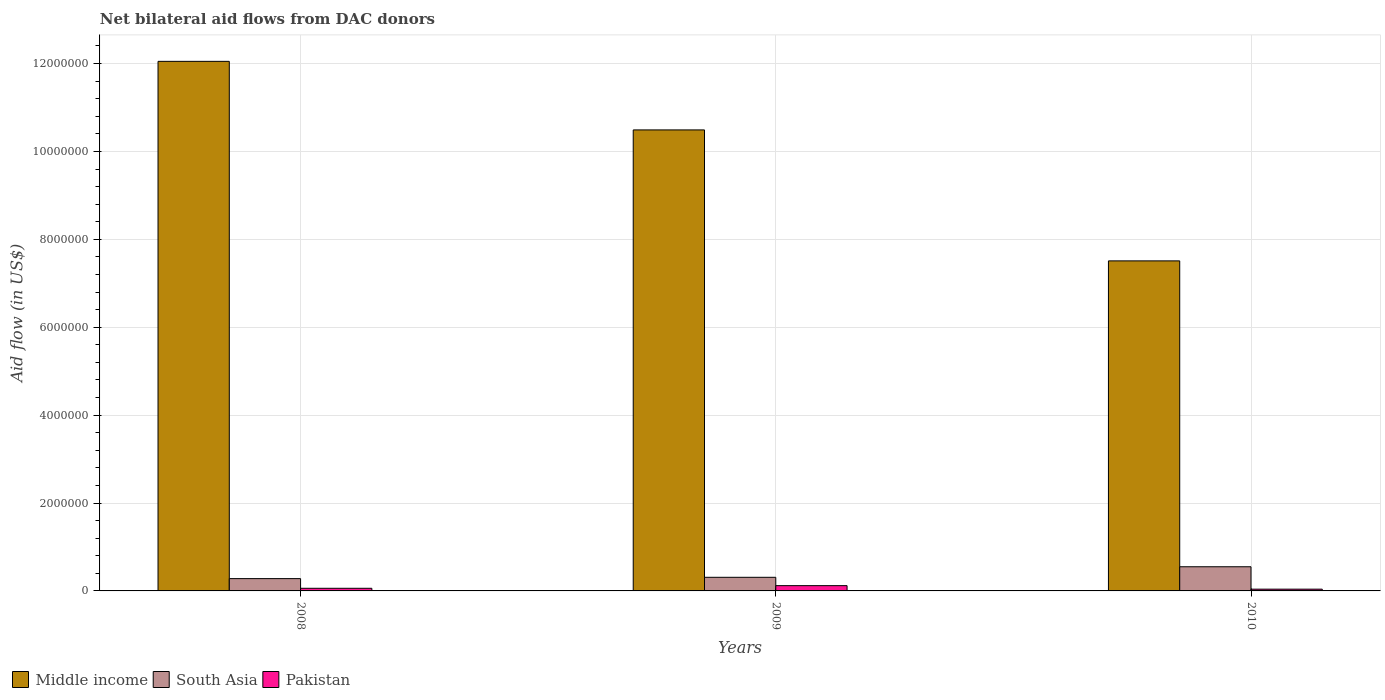How many different coloured bars are there?
Offer a terse response. 3. Are the number of bars on each tick of the X-axis equal?
Keep it short and to the point. Yes. How many bars are there on the 1st tick from the left?
Provide a short and direct response. 3. How many bars are there on the 1st tick from the right?
Offer a terse response. 3. In how many cases, is the number of bars for a given year not equal to the number of legend labels?
Your response must be concise. 0. What is the net bilateral aid flow in Pakistan in 2010?
Offer a very short reply. 4.00e+04. Across all years, what is the maximum net bilateral aid flow in South Asia?
Provide a short and direct response. 5.50e+05. In which year was the net bilateral aid flow in Pakistan minimum?
Your response must be concise. 2010. What is the total net bilateral aid flow in Middle income in the graph?
Give a very brief answer. 3.00e+07. What is the difference between the net bilateral aid flow in Middle income in 2009 and that in 2010?
Your answer should be very brief. 2.98e+06. What is the difference between the net bilateral aid flow in Pakistan in 2008 and the net bilateral aid flow in South Asia in 2010?
Give a very brief answer. -4.90e+05. What is the average net bilateral aid flow in Pakistan per year?
Your answer should be very brief. 7.33e+04. In the year 2008, what is the difference between the net bilateral aid flow in Pakistan and net bilateral aid flow in South Asia?
Ensure brevity in your answer.  -2.20e+05. In how many years, is the net bilateral aid flow in Pakistan greater than 5200000 US$?
Provide a succinct answer. 0. What is the ratio of the net bilateral aid flow in South Asia in 2008 to that in 2009?
Your answer should be very brief. 0.9. Is the difference between the net bilateral aid flow in Pakistan in 2008 and 2009 greater than the difference between the net bilateral aid flow in South Asia in 2008 and 2009?
Keep it short and to the point. No. What is the difference between the highest and the second highest net bilateral aid flow in Pakistan?
Offer a terse response. 6.00e+04. What does the 3rd bar from the left in 2010 represents?
Offer a very short reply. Pakistan. What does the 3rd bar from the right in 2008 represents?
Offer a terse response. Middle income. Is it the case that in every year, the sum of the net bilateral aid flow in Middle income and net bilateral aid flow in South Asia is greater than the net bilateral aid flow in Pakistan?
Your answer should be compact. Yes. How many bars are there?
Offer a terse response. 9. Are all the bars in the graph horizontal?
Your answer should be compact. No. Are the values on the major ticks of Y-axis written in scientific E-notation?
Keep it short and to the point. No. Where does the legend appear in the graph?
Offer a terse response. Bottom left. How are the legend labels stacked?
Ensure brevity in your answer.  Horizontal. What is the title of the graph?
Provide a succinct answer. Net bilateral aid flows from DAC donors. Does "Hungary" appear as one of the legend labels in the graph?
Offer a very short reply. No. What is the label or title of the Y-axis?
Provide a short and direct response. Aid flow (in US$). What is the Aid flow (in US$) of Middle income in 2008?
Provide a short and direct response. 1.20e+07. What is the Aid flow (in US$) in South Asia in 2008?
Provide a short and direct response. 2.80e+05. What is the Aid flow (in US$) of Middle income in 2009?
Keep it short and to the point. 1.05e+07. What is the Aid flow (in US$) in Pakistan in 2009?
Your answer should be compact. 1.20e+05. What is the Aid flow (in US$) in Middle income in 2010?
Give a very brief answer. 7.51e+06. What is the Aid flow (in US$) of South Asia in 2010?
Give a very brief answer. 5.50e+05. Across all years, what is the maximum Aid flow (in US$) in Middle income?
Your answer should be very brief. 1.20e+07. Across all years, what is the maximum Aid flow (in US$) in Pakistan?
Offer a very short reply. 1.20e+05. Across all years, what is the minimum Aid flow (in US$) in Middle income?
Your answer should be very brief. 7.51e+06. Across all years, what is the minimum Aid flow (in US$) of Pakistan?
Keep it short and to the point. 4.00e+04. What is the total Aid flow (in US$) of Middle income in the graph?
Your answer should be compact. 3.00e+07. What is the total Aid flow (in US$) in South Asia in the graph?
Offer a very short reply. 1.14e+06. What is the difference between the Aid flow (in US$) of Middle income in 2008 and that in 2009?
Offer a terse response. 1.56e+06. What is the difference between the Aid flow (in US$) in Middle income in 2008 and that in 2010?
Your response must be concise. 4.54e+06. What is the difference between the Aid flow (in US$) of South Asia in 2008 and that in 2010?
Offer a terse response. -2.70e+05. What is the difference between the Aid flow (in US$) in Pakistan in 2008 and that in 2010?
Offer a very short reply. 2.00e+04. What is the difference between the Aid flow (in US$) in Middle income in 2009 and that in 2010?
Your answer should be very brief. 2.98e+06. What is the difference between the Aid flow (in US$) in Pakistan in 2009 and that in 2010?
Give a very brief answer. 8.00e+04. What is the difference between the Aid flow (in US$) in Middle income in 2008 and the Aid flow (in US$) in South Asia in 2009?
Your answer should be compact. 1.17e+07. What is the difference between the Aid flow (in US$) in Middle income in 2008 and the Aid flow (in US$) in Pakistan in 2009?
Ensure brevity in your answer.  1.19e+07. What is the difference between the Aid flow (in US$) in South Asia in 2008 and the Aid flow (in US$) in Pakistan in 2009?
Give a very brief answer. 1.60e+05. What is the difference between the Aid flow (in US$) of Middle income in 2008 and the Aid flow (in US$) of South Asia in 2010?
Your answer should be compact. 1.15e+07. What is the difference between the Aid flow (in US$) of Middle income in 2008 and the Aid flow (in US$) of Pakistan in 2010?
Make the answer very short. 1.20e+07. What is the difference between the Aid flow (in US$) of South Asia in 2008 and the Aid flow (in US$) of Pakistan in 2010?
Ensure brevity in your answer.  2.40e+05. What is the difference between the Aid flow (in US$) of Middle income in 2009 and the Aid flow (in US$) of South Asia in 2010?
Give a very brief answer. 9.94e+06. What is the difference between the Aid flow (in US$) in Middle income in 2009 and the Aid flow (in US$) in Pakistan in 2010?
Ensure brevity in your answer.  1.04e+07. What is the difference between the Aid flow (in US$) of South Asia in 2009 and the Aid flow (in US$) of Pakistan in 2010?
Give a very brief answer. 2.70e+05. What is the average Aid flow (in US$) of Middle income per year?
Give a very brief answer. 1.00e+07. What is the average Aid flow (in US$) in Pakistan per year?
Ensure brevity in your answer.  7.33e+04. In the year 2008, what is the difference between the Aid flow (in US$) of Middle income and Aid flow (in US$) of South Asia?
Your response must be concise. 1.18e+07. In the year 2008, what is the difference between the Aid flow (in US$) in Middle income and Aid flow (in US$) in Pakistan?
Your response must be concise. 1.20e+07. In the year 2008, what is the difference between the Aid flow (in US$) of South Asia and Aid flow (in US$) of Pakistan?
Keep it short and to the point. 2.20e+05. In the year 2009, what is the difference between the Aid flow (in US$) of Middle income and Aid flow (in US$) of South Asia?
Your response must be concise. 1.02e+07. In the year 2009, what is the difference between the Aid flow (in US$) of Middle income and Aid flow (in US$) of Pakistan?
Ensure brevity in your answer.  1.04e+07. In the year 2009, what is the difference between the Aid flow (in US$) in South Asia and Aid flow (in US$) in Pakistan?
Your answer should be compact. 1.90e+05. In the year 2010, what is the difference between the Aid flow (in US$) of Middle income and Aid flow (in US$) of South Asia?
Provide a succinct answer. 6.96e+06. In the year 2010, what is the difference between the Aid flow (in US$) of Middle income and Aid flow (in US$) of Pakistan?
Keep it short and to the point. 7.47e+06. In the year 2010, what is the difference between the Aid flow (in US$) of South Asia and Aid flow (in US$) of Pakistan?
Offer a very short reply. 5.10e+05. What is the ratio of the Aid flow (in US$) in Middle income in 2008 to that in 2009?
Give a very brief answer. 1.15. What is the ratio of the Aid flow (in US$) of South Asia in 2008 to that in 2009?
Give a very brief answer. 0.9. What is the ratio of the Aid flow (in US$) in Middle income in 2008 to that in 2010?
Your answer should be compact. 1.6. What is the ratio of the Aid flow (in US$) in South Asia in 2008 to that in 2010?
Provide a short and direct response. 0.51. What is the ratio of the Aid flow (in US$) of Pakistan in 2008 to that in 2010?
Your response must be concise. 1.5. What is the ratio of the Aid flow (in US$) in Middle income in 2009 to that in 2010?
Your answer should be compact. 1.4. What is the ratio of the Aid flow (in US$) in South Asia in 2009 to that in 2010?
Your answer should be very brief. 0.56. What is the difference between the highest and the second highest Aid flow (in US$) in Middle income?
Provide a succinct answer. 1.56e+06. What is the difference between the highest and the second highest Aid flow (in US$) in South Asia?
Your answer should be very brief. 2.40e+05. What is the difference between the highest and the lowest Aid flow (in US$) in Middle income?
Your response must be concise. 4.54e+06. What is the difference between the highest and the lowest Aid flow (in US$) in Pakistan?
Your answer should be very brief. 8.00e+04. 